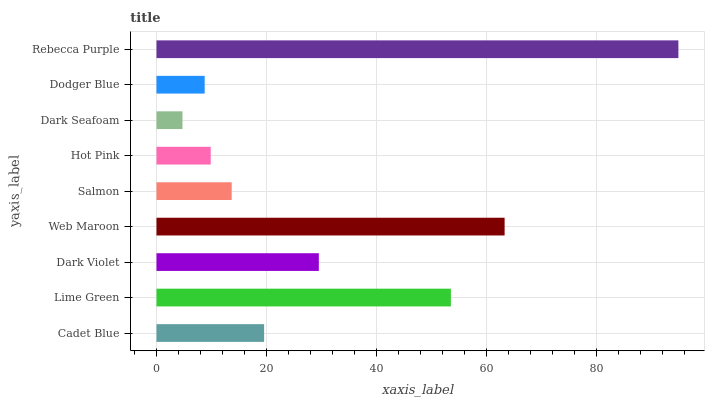Is Dark Seafoam the minimum?
Answer yes or no. Yes. Is Rebecca Purple the maximum?
Answer yes or no. Yes. Is Lime Green the minimum?
Answer yes or no. No. Is Lime Green the maximum?
Answer yes or no. No. Is Lime Green greater than Cadet Blue?
Answer yes or no. Yes. Is Cadet Blue less than Lime Green?
Answer yes or no. Yes. Is Cadet Blue greater than Lime Green?
Answer yes or no. No. Is Lime Green less than Cadet Blue?
Answer yes or no. No. Is Cadet Blue the high median?
Answer yes or no. Yes. Is Cadet Blue the low median?
Answer yes or no. Yes. Is Dodger Blue the high median?
Answer yes or no. No. Is Web Maroon the low median?
Answer yes or no. No. 